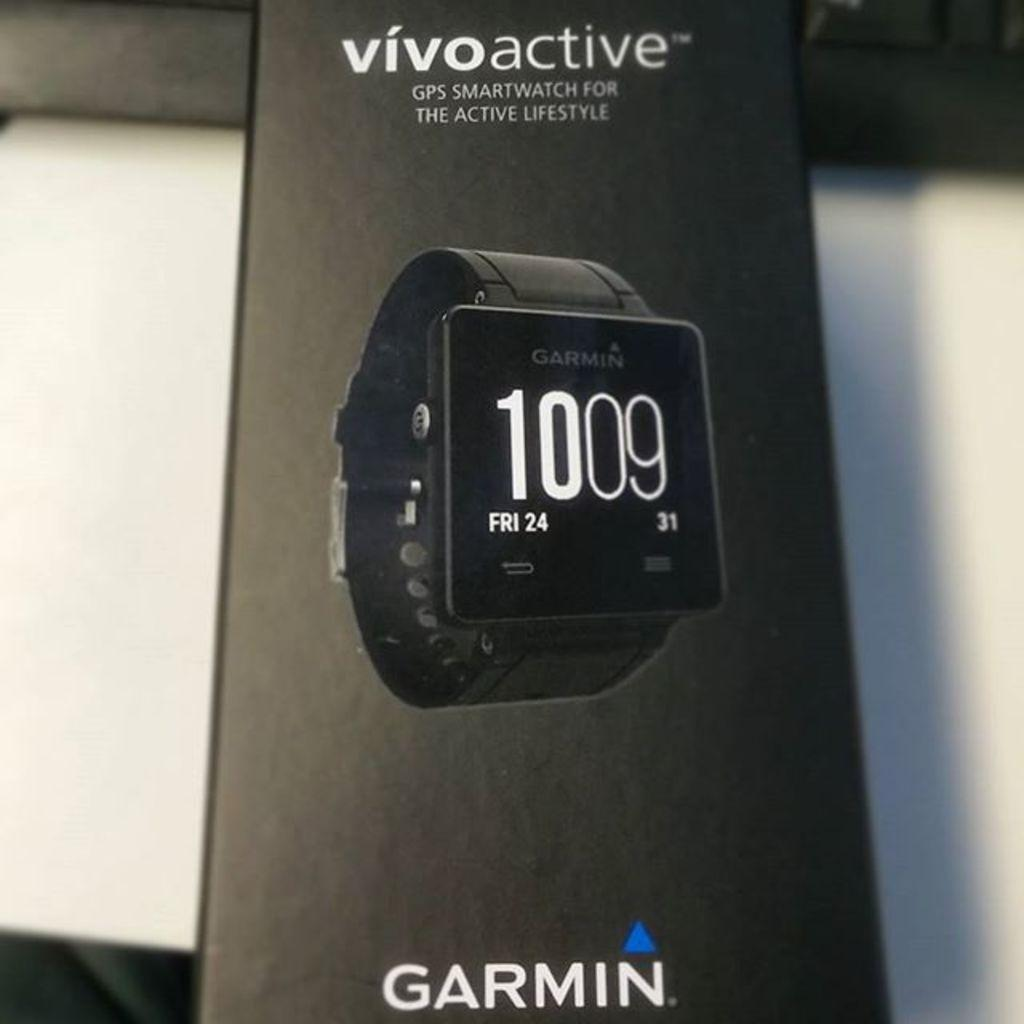<image>
Present a compact description of the photo's key features. A Garmin product is pictured on a box, and shows the date as Friday the 24th. 